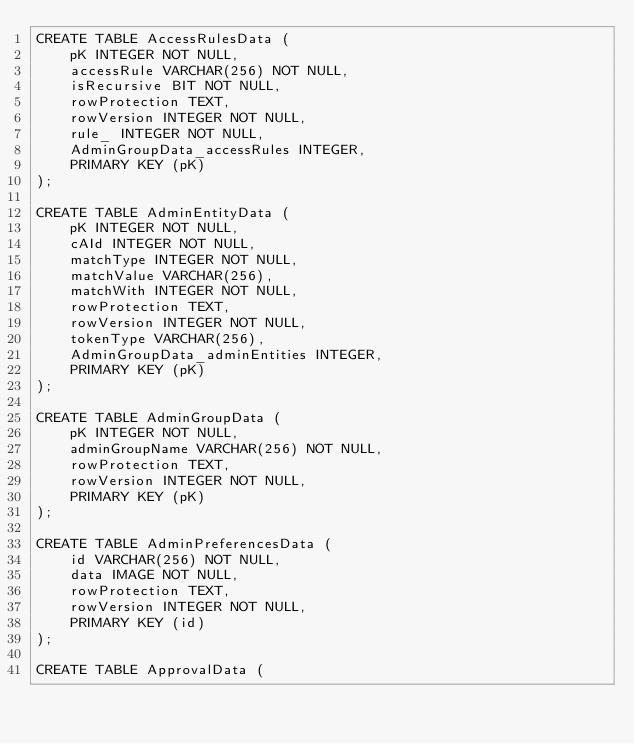Convert code to text. <code><loc_0><loc_0><loc_500><loc_500><_SQL_>CREATE TABLE AccessRulesData (
    pK INTEGER NOT NULL,
    accessRule VARCHAR(256) NOT NULL,
    isRecursive BIT NOT NULL,
    rowProtection TEXT,
    rowVersion INTEGER NOT NULL,
    rule_ INTEGER NOT NULL,
    AdminGroupData_accessRules INTEGER,
    PRIMARY KEY (pK)
);

CREATE TABLE AdminEntityData (
    pK INTEGER NOT NULL,
    cAId INTEGER NOT NULL,
    matchType INTEGER NOT NULL,
    matchValue VARCHAR(256),
    matchWith INTEGER NOT NULL,
    rowProtection TEXT,
    rowVersion INTEGER NOT NULL,
    tokenType VARCHAR(256),
    AdminGroupData_adminEntities INTEGER,
    PRIMARY KEY (pK)
);

CREATE TABLE AdminGroupData (
    pK INTEGER NOT NULL,
    adminGroupName VARCHAR(256) NOT NULL,
    rowProtection TEXT,
    rowVersion INTEGER NOT NULL,
    PRIMARY KEY (pK)
);

CREATE TABLE AdminPreferencesData (
    id VARCHAR(256) NOT NULL,
    data IMAGE NOT NULL,
    rowProtection TEXT,
    rowVersion INTEGER NOT NULL,
    PRIMARY KEY (id)
);

CREATE TABLE ApprovalData (</code> 